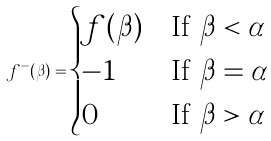<formula> <loc_0><loc_0><loc_500><loc_500>f ^ { - } ( \beta ) = \begin{cases} f ( \beta ) & \text {If $\beta < \alpha$} \\ - 1 & \text {If $\beta=\alpha$} \\ 0 & \text {If $\beta > \alpha$} \end{cases}</formula> 